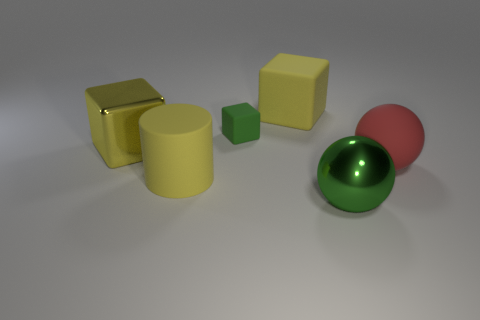Subtract all green rubber blocks. How many blocks are left? 2 Subtract all green cubes. How many cubes are left? 2 Add 3 cylinders. How many objects exist? 9 Subtract 1 blocks. How many blocks are left? 2 Subtract all spheres. How many objects are left? 4 Subtract all big blue blocks. Subtract all large matte cylinders. How many objects are left? 5 Add 4 red matte balls. How many red matte balls are left? 5 Add 6 purple shiny balls. How many purple shiny balls exist? 6 Subtract 2 yellow cubes. How many objects are left? 4 Subtract all red blocks. Subtract all cyan balls. How many blocks are left? 3 